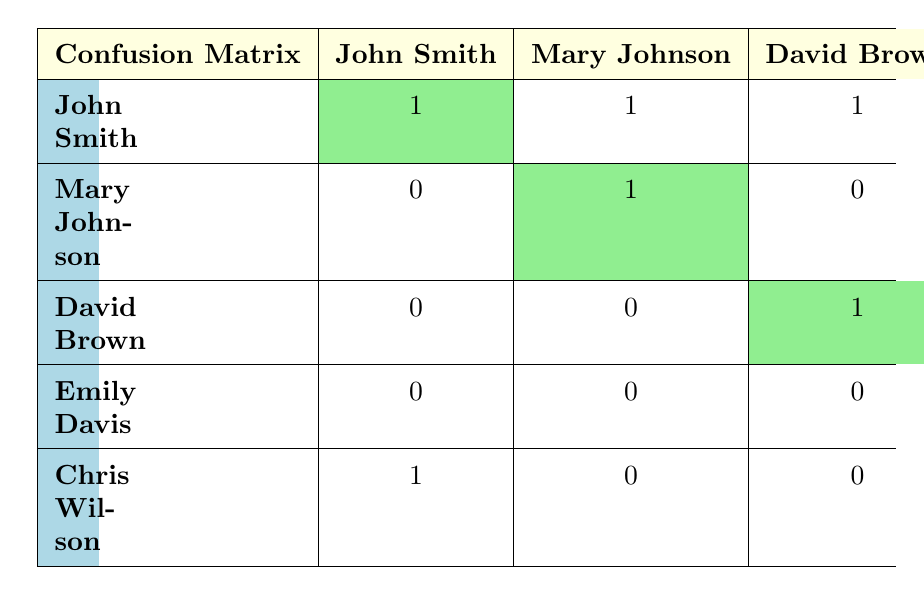What is the number of times "John Smith" was correctly identified? In the confusion matrix, "John Smith" was correctly identified once, as indicated by the cell where the actual and predicted values both show "John Smith" and the correct is marked true.
Answer: 1 How many total misidentifications occurred for "Chris Wilson"? For "Chris Wilson," there are two instances of misidentification as seen in the confusion matrix: one where he was predicted as "Cristopher Wilson" and another where he was predicted as "John Smith."
Answer: 2 Is "Emily Davis" correctly identified more frequently than "David Brown"? Both "Emily Davis" and "David Brown" were correctly identified once, so they have the same frequency of correct identification. Therefore, the statement is false.
Answer: No What is the total number of individuals incorrectly identified? To find the total number of incorrect identifications, we sum the false predictions: 1 misidentification for "John Smith," 1 for "Mary Johnson," 1 for "David Brown," and 1 for "Chris Wilson," which results in a total of 4 incorrect identifications.
Answer: 4 Which person had the highest number of false identifications? By examining the table, "Chris Wilson" had 2 false identifications compared to others. The maximum for false identifications refers to the row for "Chris Wilson," where there are 2 non-zero entries.
Answer: Chris Wilson What proportion of predictions for "Mary Johnson" were correct? "Mary Johnson" was correctly identified once out of a total of 2 predictions (one correct and one misidentification). We calculate the proportion as follows: 1/2 = 0.5 or 50%.
Answer: 50% How many names were completely misidentified with no correct identification? In the confusion matrix, there are no names listed without any correct identification. Every name has at least one correct identification occurrence, thus the total of completely misidentified individuals is zero.
Answer: 0 Did "Emily Davis" receive any false identifications from the predictions? Looking at the confusion matrix, we see that "Emily Davis" was identified correctly, and there are no false identifications listed for her, confirming that the answer is true.
Answer: No 